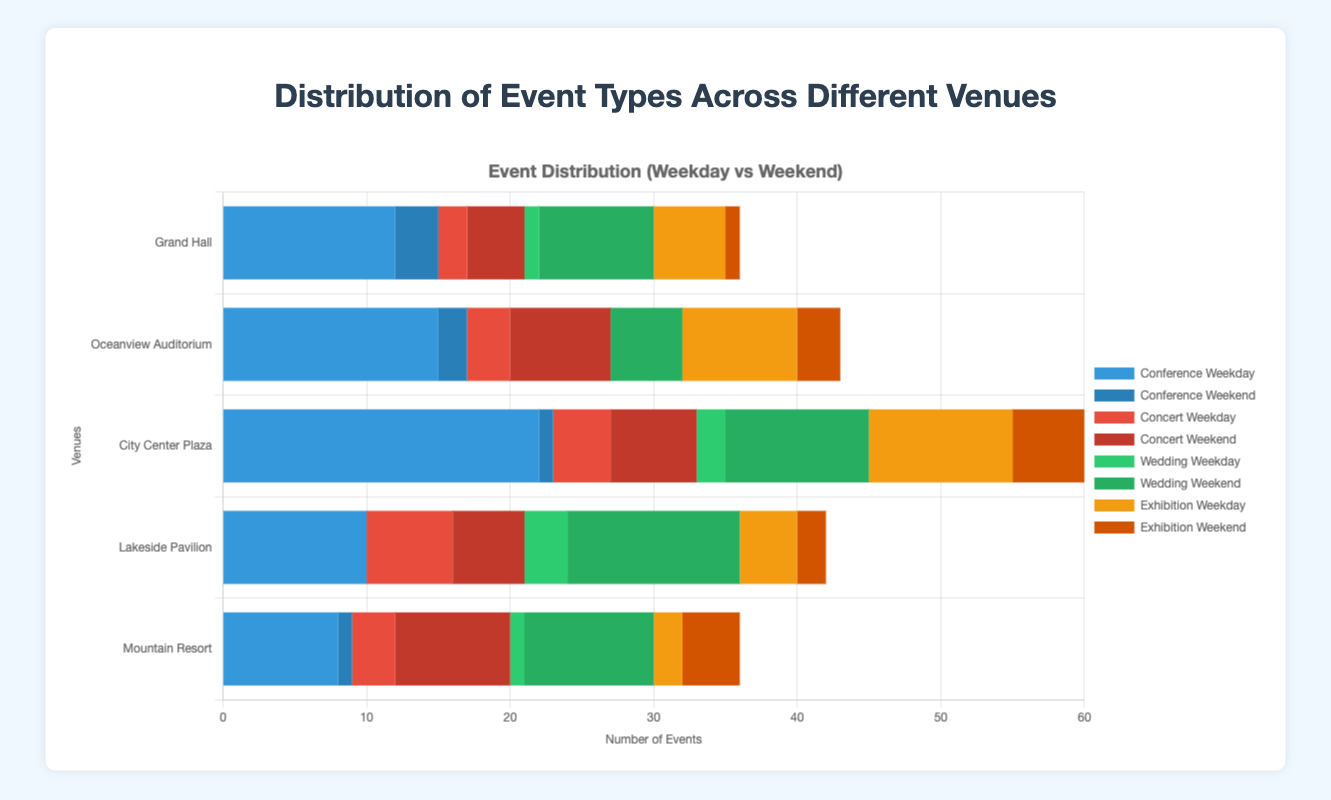Which venue has the highest number of weekday conferences? The bars representing weekday conferences are blue. Compare the lengths of the blue bars for each venue and find the one with the longest bar. "City Center Plaza" has the longest blue bar for weekday conferences, indicating the highest count.
Answer: City Center Plaza Which venue holds the most weddings on weekends? Look for the green bars representing weekend weddings for each venue's section. The longest green bar is found in the "City Center Plaza" section.
Answer: City Center Plaza How many total events does Lakeside Pavilion host during weekdays? Add the weekday counts for all event types at Lakeside Pavilion. 10 (Conference) + 6 (Concert) + 3 (Wedding) + 4 (Exhibition) = 23
Answer: 23 Compare the total number of concerts on weekends between Oceanview Auditorium and Mountain Resort. Which has more? Sum the weekend concert counts for both venues. Oceanview Auditorium: 7, Mountain Resort: 8. Compare these values to find that Mountain Resort has more.
Answer: Mountain Resort Out of all the venues, which event type is least common on weekends? Add up the weekend counts for each event type across all venues. Conferences: 3 + 2 + 1 + 0 + 1 = 7, Concerts: 4 + 7 + 6 + 5 + 8 = 30, Weddings: 8 + 5 + 10 + 12 + 9 = 44, Exhibitions: 1 + 3 + 5 + 2 + 4 = 15. Conferences are the least common.
Answer: Conference Which event type and venue combination has the fewest total events? Calculate the total events (weekday + weekend) for each event type at each venue. The fewest total is for "Wedding" at "Oceanview Auditorium," with 0 weekday and 5 weekend events.
Answer: Wedding at Oceanview Auditorium Compare the total number of events (weekday + weekend) between Grand Hall and Mountain Resort. Which venue hosts more events? Calculate the total events at each venue by summing all event counts. Grand Hall: 24 + 6 = 30, Mountain Resort: 9 + 11 = 20. Grand Hall hosts more events.
Answer: Grand Hall What is the average number of exhibitions held on weekdays across all venues? Calculate the mean by summing the weekday exhibition counts at all venues and dividing by the number of venues. (5 + 8 + 10 + 4 + 2) / 5 = 29 / 5 = 5.8
Answer: 5.8 